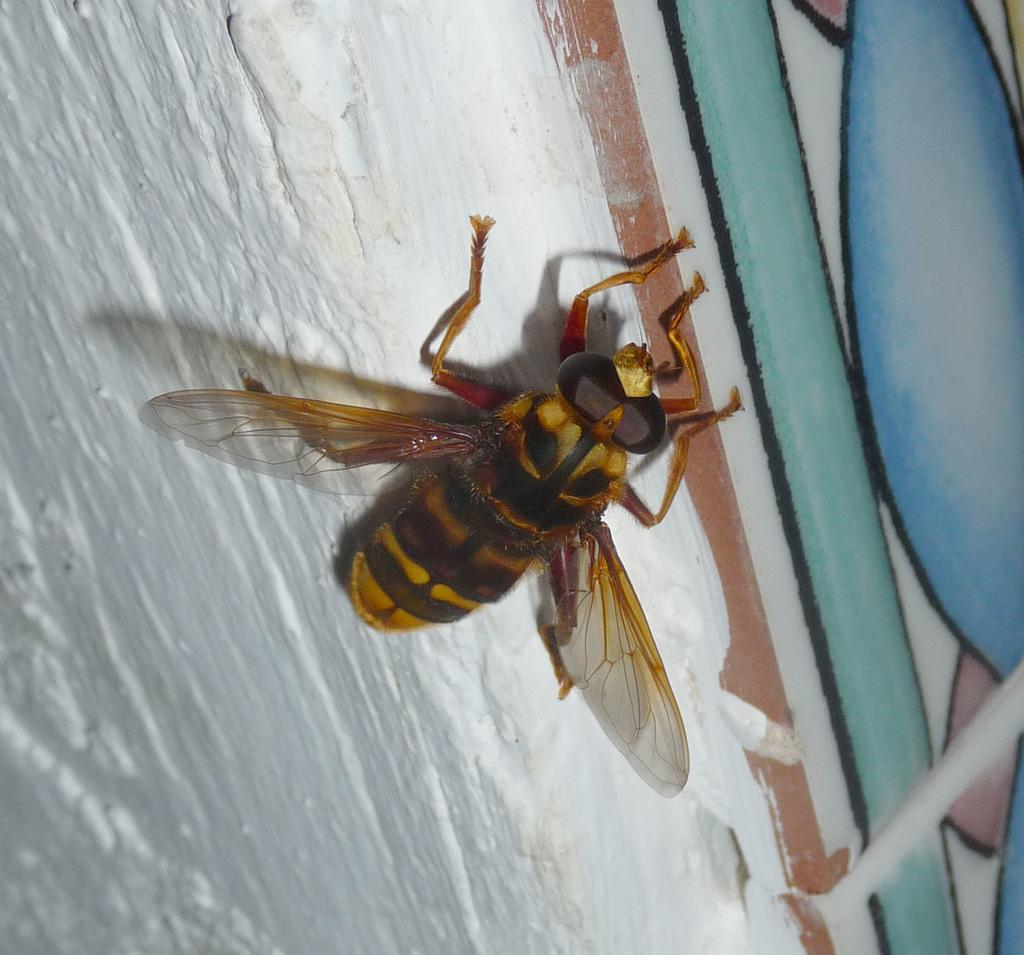What is present on the wall in the image? There is an insect on the wall in the image. What can be seen on the right side of the image? There are files with some design on the right side of the image. What type of doll can be seen attacking the insect in the image? There is no doll present in the image, nor is there any attack taking place. 